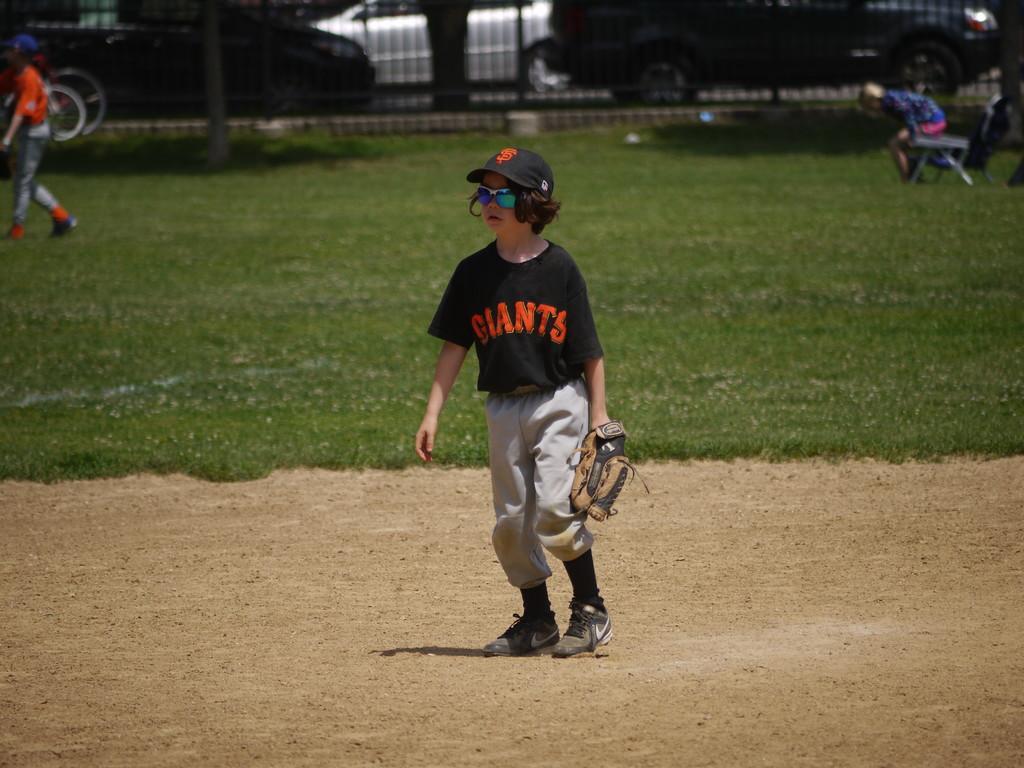In one or two sentences, can you explain what this image depicts? In this image we can see a boy standing on the ground wearing a glove. We can also see grass, some people standing, a person on a chair, a pole, a fence, the bark of a tree and some vehicles on the ground. 